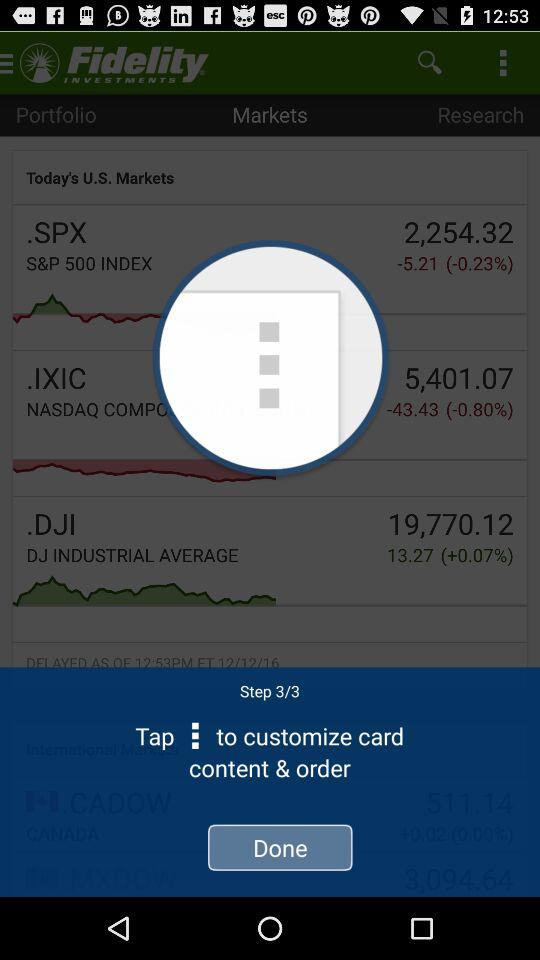What is the percentage change of the NASDAQ COMPO?
Answer the question using a single word or phrase. -0.80% 